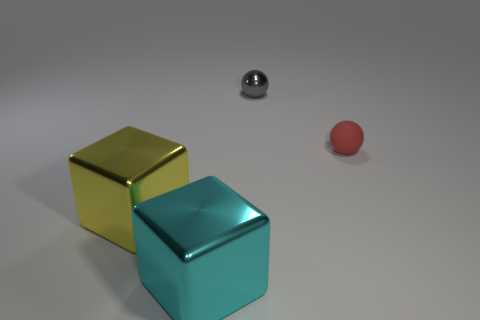The gray thing has what shape?
Ensure brevity in your answer.  Sphere. What number of things are both in front of the tiny metallic sphere and on the left side of the tiny red object?
Ensure brevity in your answer.  2. Do the matte sphere and the tiny metal ball have the same color?
Offer a very short reply. No. What is the material of the other thing that is the same shape as the small red thing?
Ensure brevity in your answer.  Metal. Is there anything else that has the same material as the gray object?
Your answer should be compact. Yes. Are there an equal number of yellow shiny things behind the gray metal object and small red spheres that are left of the yellow object?
Offer a terse response. Yes. Are the small red thing and the big yellow block made of the same material?
Give a very brief answer. No. How many cyan objects are spheres or big cubes?
Ensure brevity in your answer.  1. What number of other large metallic things have the same shape as the big yellow metallic thing?
Keep it short and to the point. 1. What material is the small gray thing?
Make the answer very short. Metal. 